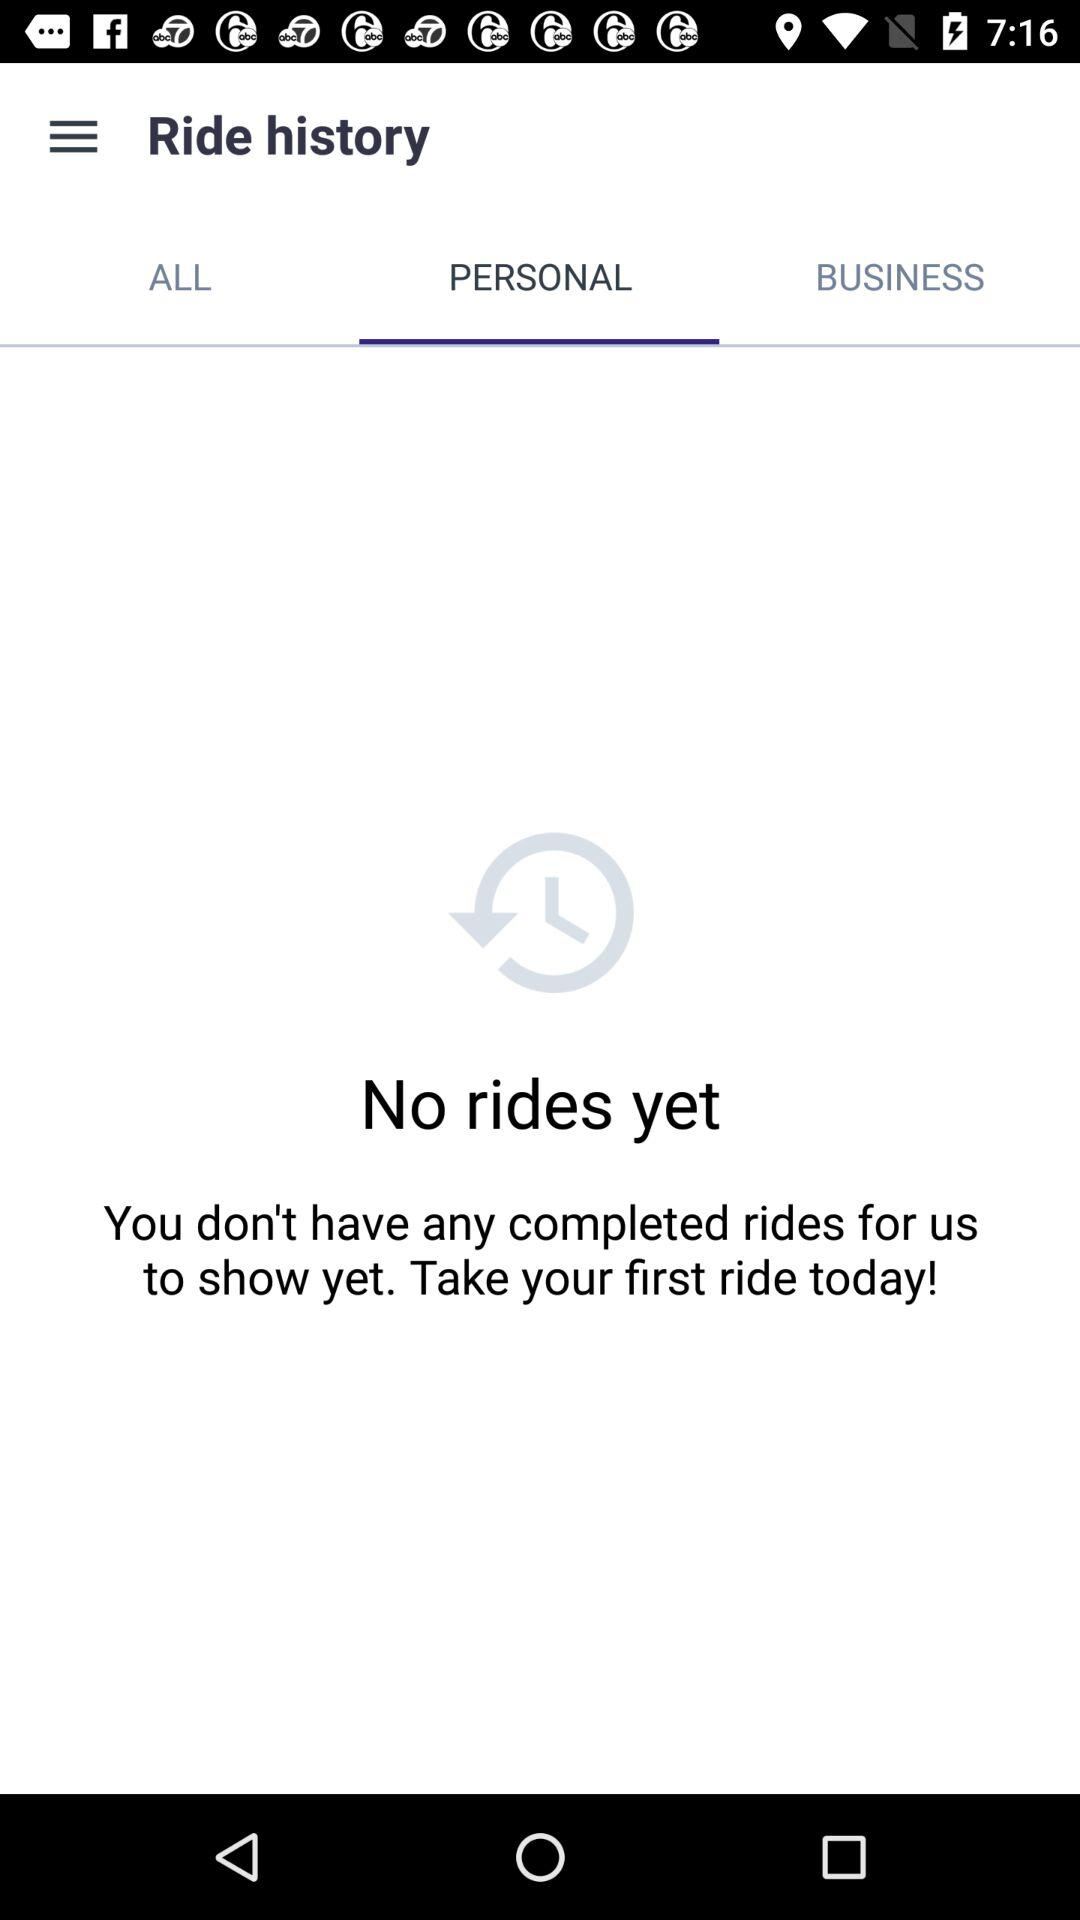How many rides have I completed?
Answer the question using a single word or phrase. 0 